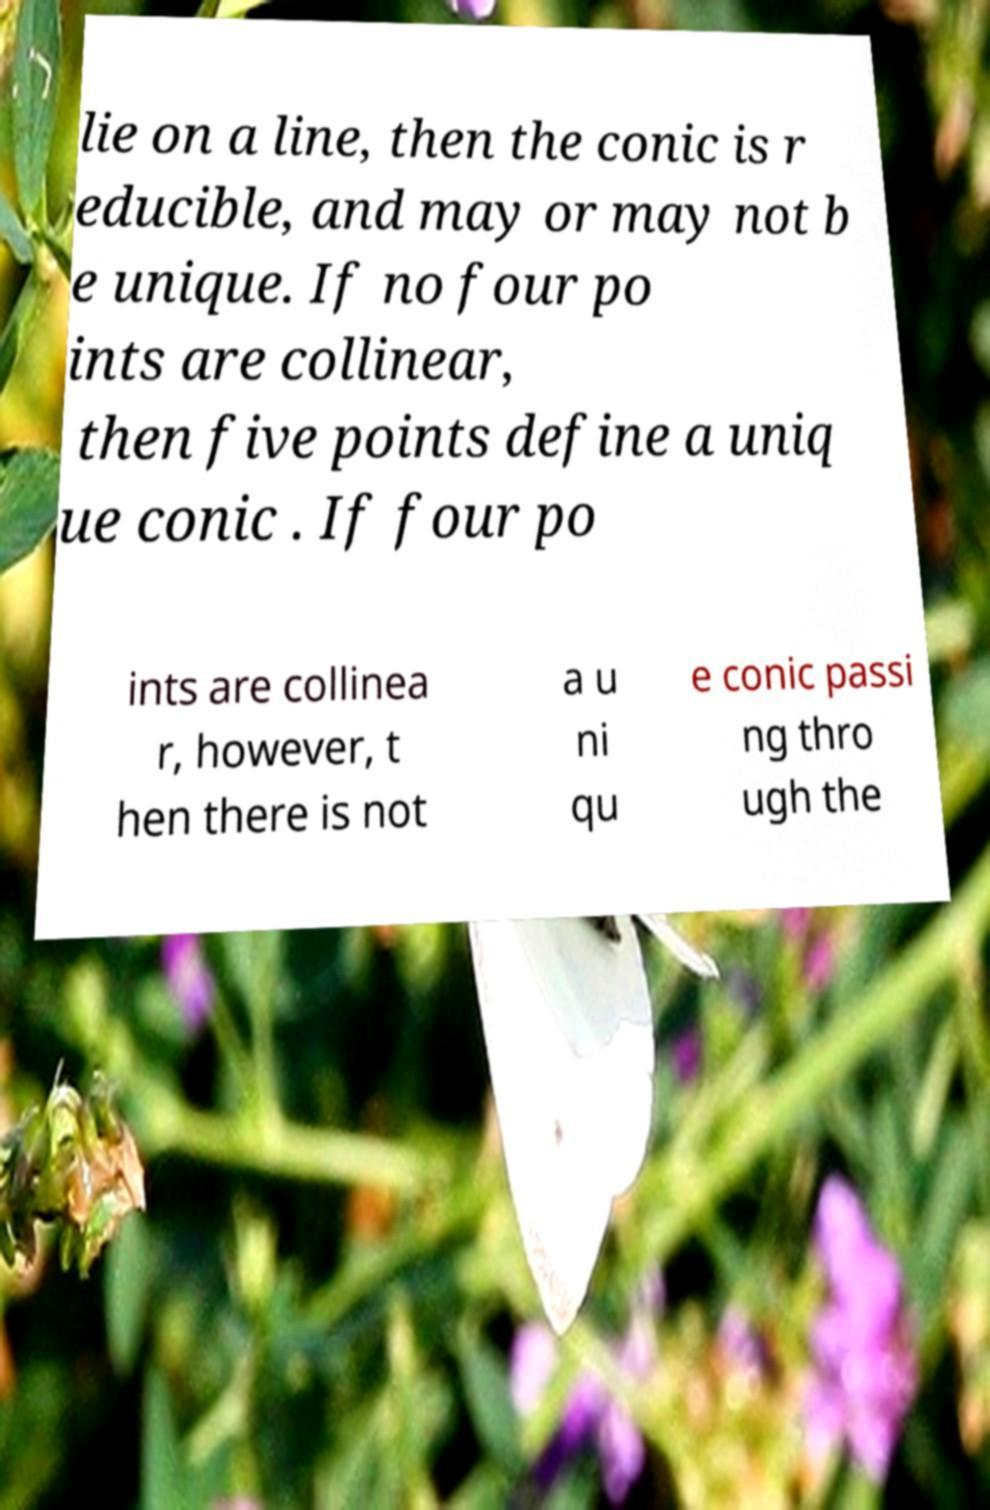I need the written content from this picture converted into text. Can you do that? lie on a line, then the conic is r educible, and may or may not b e unique. If no four po ints are collinear, then five points define a uniq ue conic . If four po ints are collinea r, however, t hen there is not a u ni qu e conic passi ng thro ugh the 